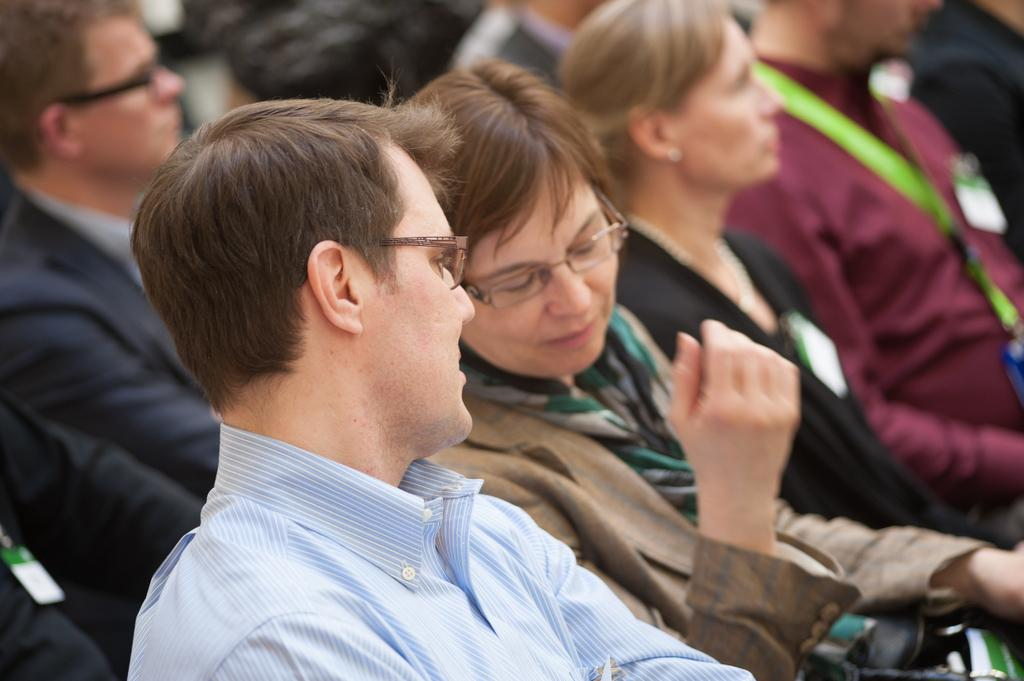Who are the main subjects in the foreground of the image? There is a man and a woman in the foreground of the image. What are the man and woman doing in the image? The man and woman are talking to each other. What can be seen in the background of the image? In the background of the image, there are persons sitting. What type of bait is the man using to catch fish in the image? There is no fishing or bait present in the image; it features a man and a woman talking to each other. What does the caption say about the conversation between the man and woman in the image? There is no caption provided with the image, so we cannot determine what it might say about the conversation. 